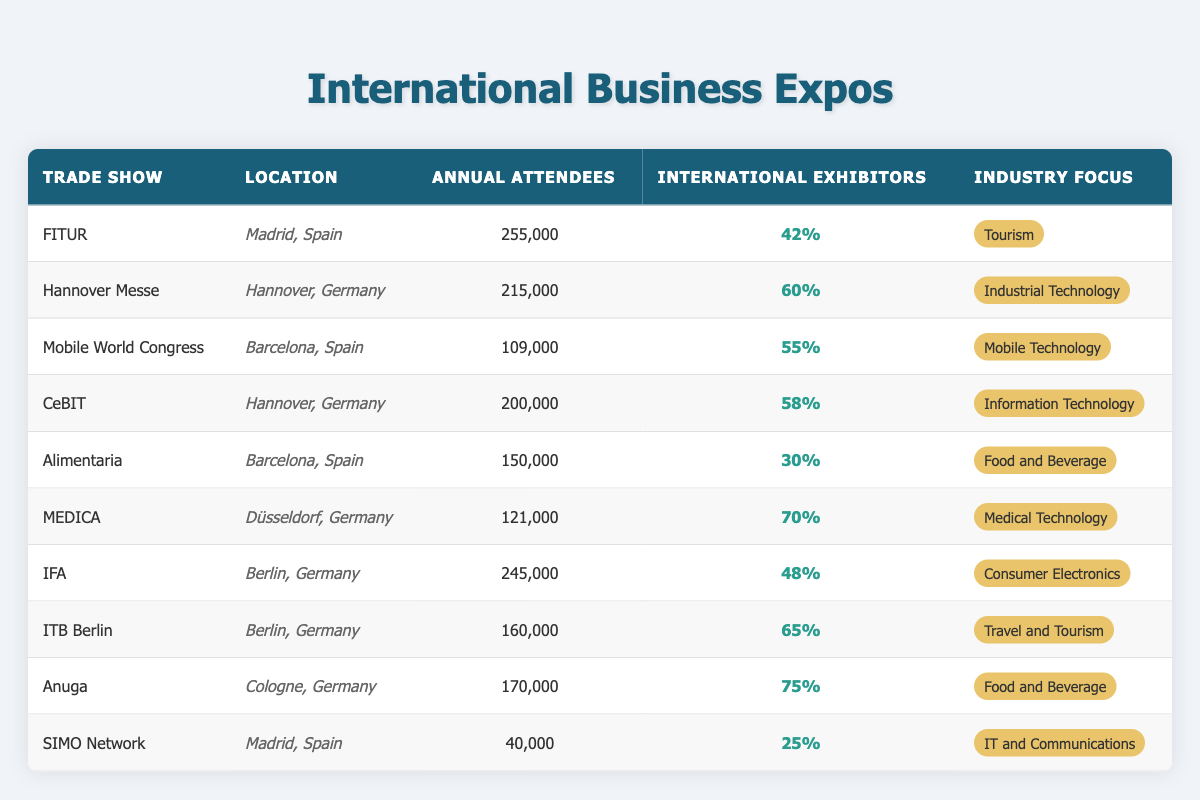What is the location of the Mobile World Congress? The table indicates that the Mobile World Congress is located in Barcelona, Spain under the "Location" column.
Answer: Barcelona, Spain Which trade show has the highest annual attendance? By reviewing the "Annual Attendees" column, FITUR has the highest attendance value of 255,000.
Answer: FITUR How many trade shows have more than 60% international exhibitors? The table shows that Hannover Messe (60%), MEDICA (70%), ITB Berlin (65%), and Anuga (75%) are the trade shows with more than 60% international exhibitors, amounting to four shows.
Answer: Four Is the percentage of international exhibitors at Alimentaria more than 40%? Alimentaria has 30% as noted in the "International Exhibitors" column, which is less than 40%. Thus, the statement is false.
Answer: No What is the average annual attendance of the trade shows located in Spain? The annual attendance of trade shows in Spain are FITUR (255,000), Mobile World Congress (109,000), and SIMO Network (40,000). Summing these gives 255,000 + 109,000 + 40,000 = 404,000. Dividing by the number of trade shows, which is 3, yields an average of 404,000 / 3 = 134,666.67, rounded gives 134,667.
Answer: 134,667 How many trade shows focused on food and beverage have international exhibitors above 50%? Two trade shows are focused on food and beverage: Alimentaria (30%) and Anuga (75%). Only Anuga exceeds 50% of international exhibitors, therefore the answer is one show.
Answer: One Which trade show in Germany has the second highest number of annual attendees? The trade shows in Germany listed are Hannover Messe (215,000), CeBIT (200,000), MEDICA (121,000), IFA (245,000), and ITB Berlin (160,000). The second highest after IFA (245,000) is Hannover Messe (215,000).
Answer: Hannover Messe Is SIMO Network the trade show with the least annual attendees? In the "Annual Attendees" column, SIMO Network has 40,000 attendees, which is indeed the lowest number compared to all other trade shows. Therefore, the answer is true.
Answer: Yes 